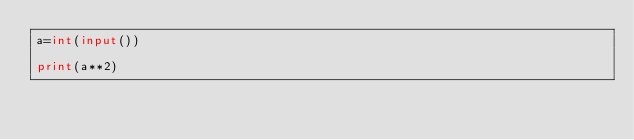Convert code to text. <code><loc_0><loc_0><loc_500><loc_500><_Python_>a=int(input())

print(a**2)</code> 